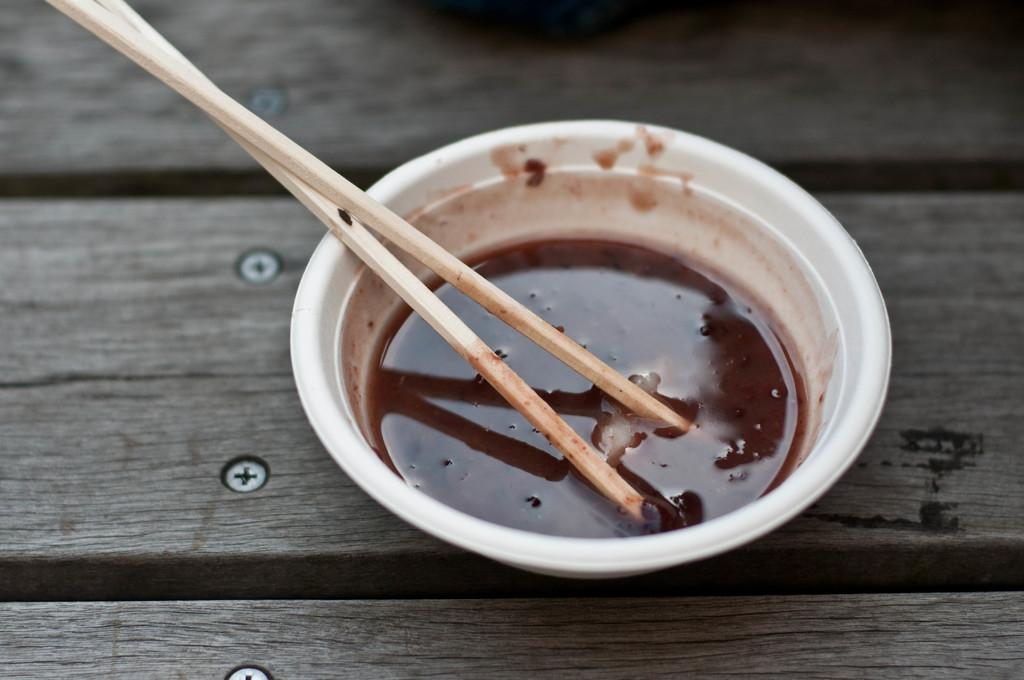What is on the wooden table in the image? There is a bowl on a wooden table in the image. What utensils are present in the image? Chopsticks are present in the image. What is inside the bowl? There is a liquid in the bowl. What type of education can be seen in the image? There is no reference to education in the image; it features a bowl on a wooden table with chopsticks and a liquid inside the bowl. 